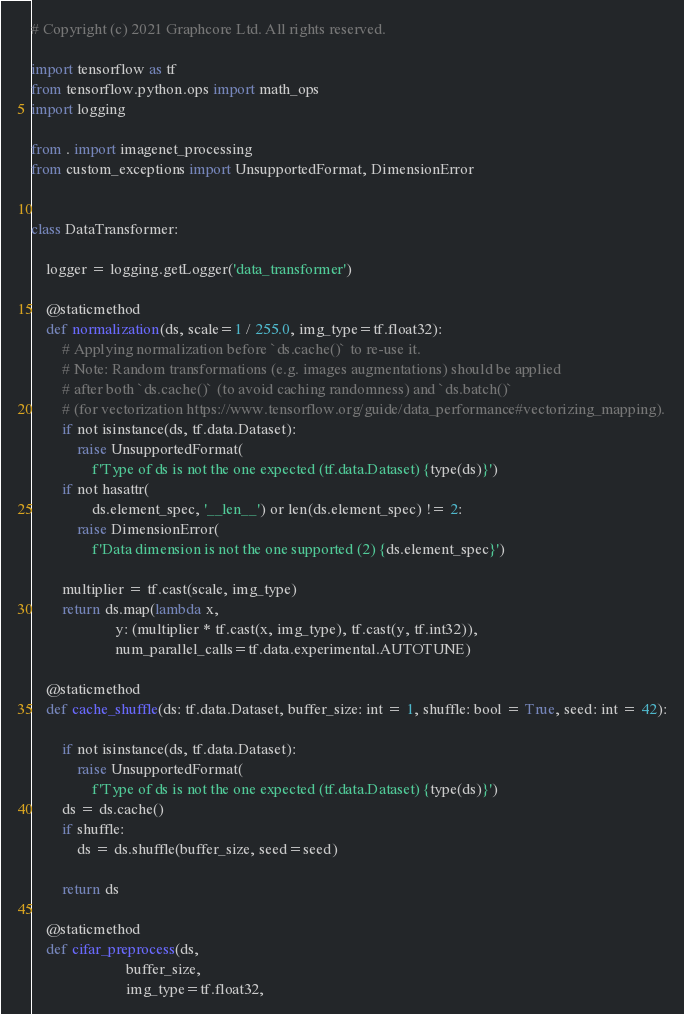<code> <loc_0><loc_0><loc_500><loc_500><_Python_># Copyright (c) 2021 Graphcore Ltd. All rights reserved.

import tensorflow as tf
from tensorflow.python.ops import math_ops
import logging

from . import imagenet_processing
from custom_exceptions import UnsupportedFormat, DimensionError


class DataTransformer:

    logger = logging.getLogger('data_transformer')

    @staticmethod
    def normalization(ds, scale=1 / 255.0, img_type=tf.float32):
        # Applying normalization before `ds.cache()` to re-use it.
        # Note: Random transformations (e.g. images augmentations) should be applied
        # after both `ds.cache()` (to avoid caching randomness) and `ds.batch()`
        # (for vectorization https://www.tensorflow.org/guide/data_performance#vectorizing_mapping).
        if not isinstance(ds, tf.data.Dataset):
            raise UnsupportedFormat(
                f'Type of ds is not the one expected (tf.data.Dataset) {type(ds)}')
        if not hasattr(
                ds.element_spec, '__len__') or len(ds.element_spec) != 2:
            raise DimensionError(
                f'Data dimension is not the one supported (2) {ds.element_spec}')

        multiplier = tf.cast(scale, img_type)
        return ds.map(lambda x,
                      y: (multiplier * tf.cast(x, img_type), tf.cast(y, tf.int32)),
                      num_parallel_calls=tf.data.experimental.AUTOTUNE)

    @staticmethod
    def cache_shuffle(ds: tf.data.Dataset, buffer_size: int = 1, shuffle: bool = True, seed: int = 42):

        if not isinstance(ds, tf.data.Dataset):
            raise UnsupportedFormat(
                f'Type of ds is not the one expected (tf.data.Dataset) {type(ds)}')
        ds = ds.cache()
        if shuffle:
            ds = ds.shuffle(buffer_size, seed=seed)

        return ds

    @staticmethod
    def cifar_preprocess(ds,
                         buffer_size,
                         img_type=tf.float32,</code> 